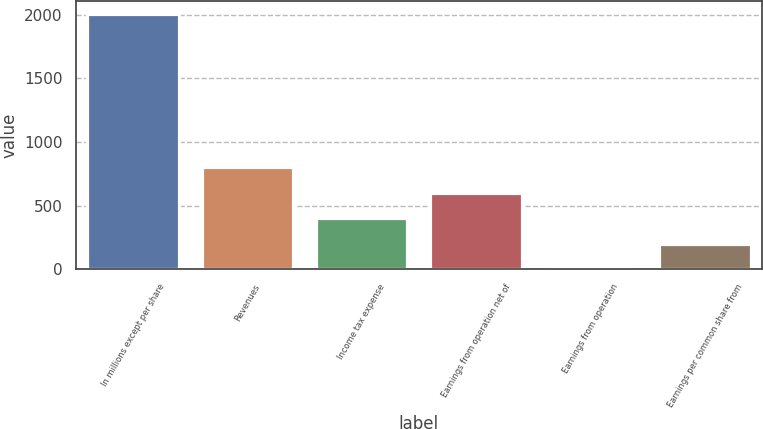<chart> <loc_0><loc_0><loc_500><loc_500><bar_chart><fcel>In millions except per share<fcel>Revenues<fcel>Income tax expense<fcel>Earnings from operation net of<fcel>Earnings from operation<fcel>Earnings per common share from<nl><fcel>2004<fcel>801.64<fcel>400.85<fcel>601.25<fcel>0.05<fcel>200.45<nl></chart> 